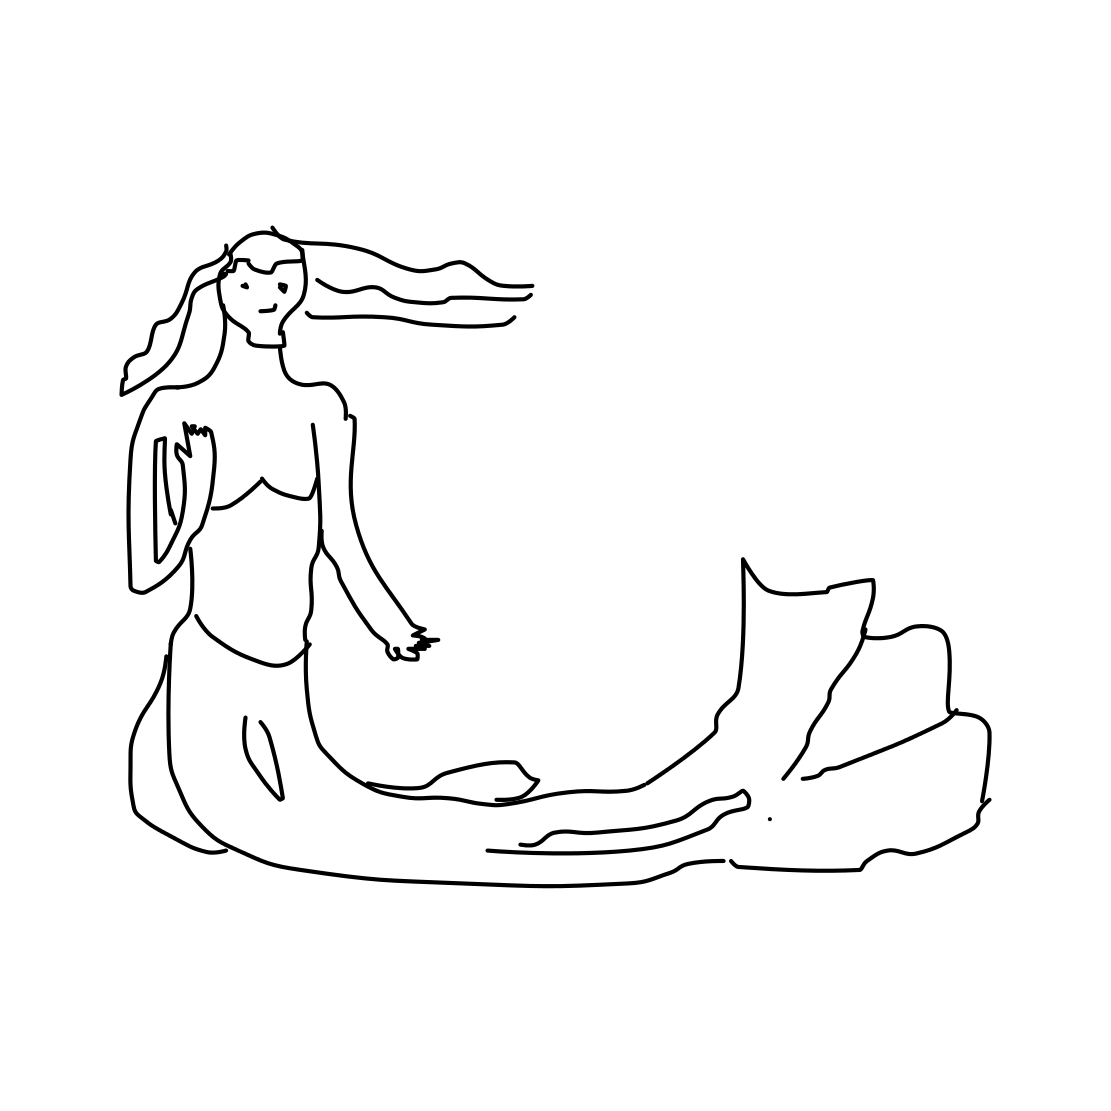In the scene, is a flashlight in it? No, the image does not contain a flashlight. It features a mermaid sitting on a rock with no visible objects around that resemble a flashlight. 